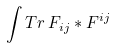<formula> <loc_0><loc_0><loc_500><loc_500>\int T r \, F _ { i j } * F ^ { i j }</formula> 